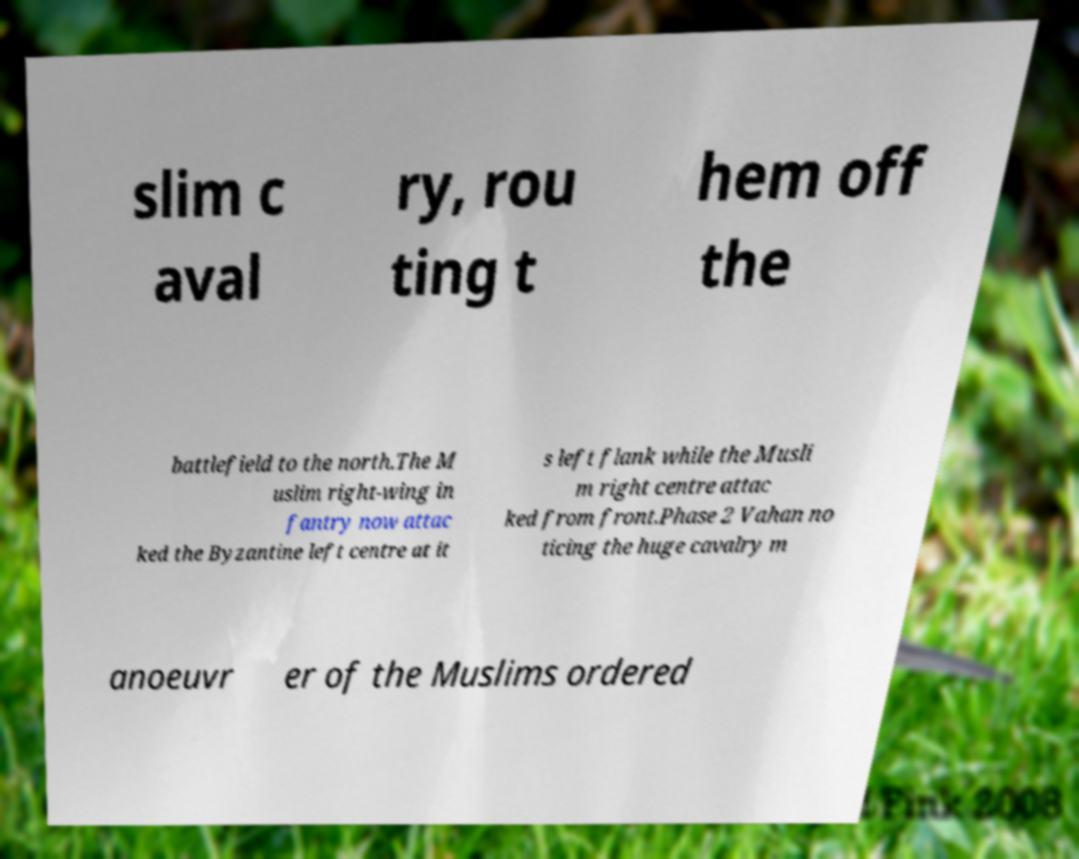What messages or text are displayed in this image? I need them in a readable, typed format. slim c aval ry, rou ting t hem off the battlefield to the north.The M uslim right-wing in fantry now attac ked the Byzantine left centre at it s left flank while the Musli m right centre attac ked from front.Phase 2 Vahan no ticing the huge cavalry m anoeuvr er of the Muslims ordered 